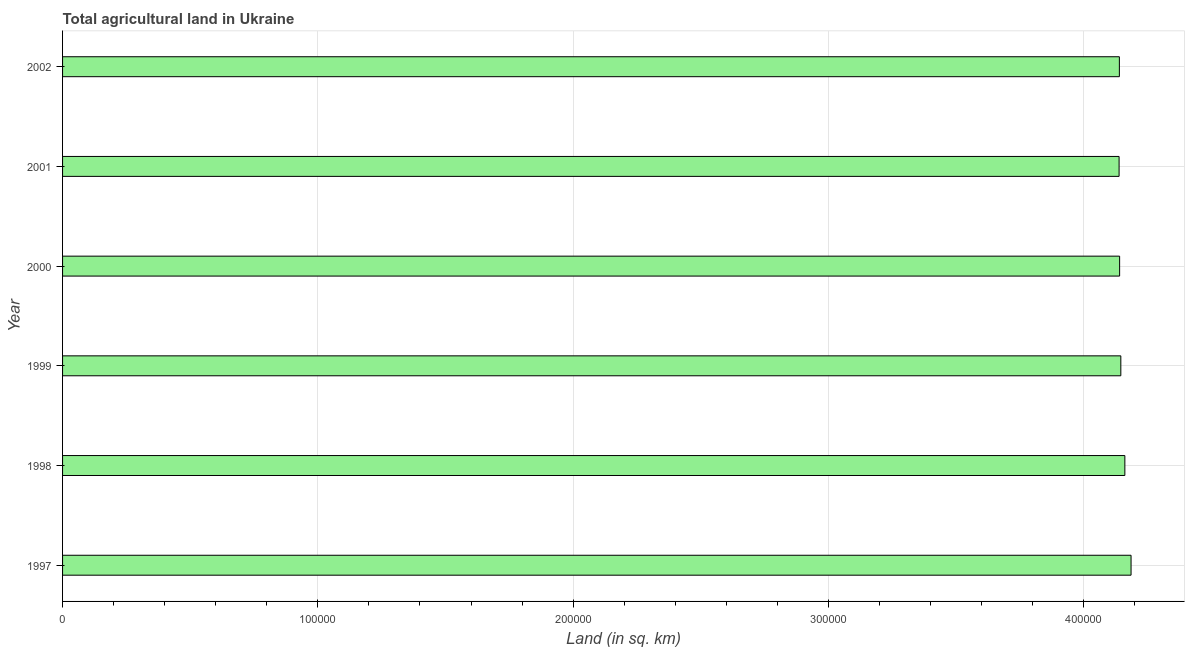What is the title of the graph?
Keep it short and to the point. Total agricultural land in Ukraine. What is the label or title of the X-axis?
Make the answer very short. Land (in sq. km). What is the agricultural land in 1999?
Provide a short and direct response. 4.15e+05. Across all years, what is the maximum agricultural land?
Give a very brief answer. 4.19e+05. Across all years, what is the minimum agricultural land?
Your answer should be compact. 4.14e+05. In which year was the agricultural land maximum?
Give a very brief answer. 1997. In which year was the agricultural land minimum?
Give a very brief answer. 2001. What is the sum of the agricultural land?
Make the answer very short. 2.49e+06. What is the difference between the agricultural land in 2001 and 2002?
Your answer should be compact. -110. What is the average agricultural land per year?
Your response must be concise. 4.15e+05. What is the median agricultural land?
Your answer should be compact. 4.14e+05. In how many years, is the agricultural land greater than 20000 sq. km?
Provide a succinct answer. 6. What is the ratio of the agricultural land in 2000 to that in 2002?
Your response must be concise. 1. Is the difference between the agricultural land in 1998 and 1999 greater than the difference between any two years?
Give a very brief answer. No. What is the difference between the highest and the second highest agricultural land?
Your response must be concise. 2430. What is the difference between the highest and the lowest agricultural land?
Your response must be concise. 4690. Are all the bars in the graph horizontal?
Provide a short and direct response. Yes. What is the Land (in sq. km) in 1997?
Provide a succinct answer. 4.19e+05. What is the Land (in sq. km) in 1998?
Your response must be concise. 4.16e+05. What is the Land (in sq. km) in 1999?
Your answer should be compact. 4.15e+05. What is the Land (in sq. km) of 2000?
Give a very brief answer. 4.14e+05. What is the Land (in sq. km) of 2001?
Keep it short and to the point. 4.14e+05. What is the Land (in sq. km) in 2002?
Offer a terse response. 4.14e+05. What is the difference between the Land (in sq. km) in 1997 and 1998?
Offer a very short reply. 2430. What is the difference between the Land (in sq. km) in 1997 and 1999?
Keep it short and to the point. 4010. What is the difference between the Land (in sq. km) in 1997 and 2000?
Provide a succinct answer. 4480. What is the difference between the Land (in sq. km) in 1997 and 2001?
Give a very brief answer. 4690. What is the difference between the Land (in sq. km) in 1997 and 2002?
Provide a short and direct response. 4580. What is the difference between the Land (in sq. km) in 1998 and 1999?
Make the answer very short. 1580. What is the difference between the Land (in sq. km) in 1998 and 2000?
Ensure brevity in your answer.  2050. What is the difference between the Land (in sq. km) in 1998 and 2001?
Offer a terse response. 2260. What is the difference between the Land (in sq. km) in 1998 and 2002?
Offer a very short reply. 2150. What is the difference between the Land (in sq. km) in 1999 and 2000?
Your response must be concise. 470. What is the difference between the Land (in sq. km) in 1999 and 2001?
Your answer should be compact. 680. What is the difference between the Land (in sq. km) in 1999 and 2002?
Ensure brevity in your answer.  570. What is the difference between the Land (in sq. km) in 2000 and 2001?
Ensure brevity in your answer.  210. What is the difference between the Land (in sq. km) in 2000 and 2002?
Keep it short and to the point. 100. What is the difference between the Land (in sq. km) in 2001 and 2002?
Make the answer very short. -110. What is the ratio of the Land (in sq. km) in 1997 to that in 2001?
Offer a very short reply. 1.01. What is the ratio of the Land (in sq. km) in 1998 to that in 1999?
Offer a terse response. 1. What is the ratio of the Land (in sq. km) in 1998 to that in 2000?
Your answer should be compact. 1. What is the ratio of the Land (in sq. km) in 1998 to that in 2001?
Offer a very short reply. 1. What is the ratio of the Land (in sq. km) in 1999 to that in 2000?
Give a very brief answer. 1. What is the ratio of the Land (in sq. km) in 1999 to that in 2002?
Ensure brevity in your answer.  1. 